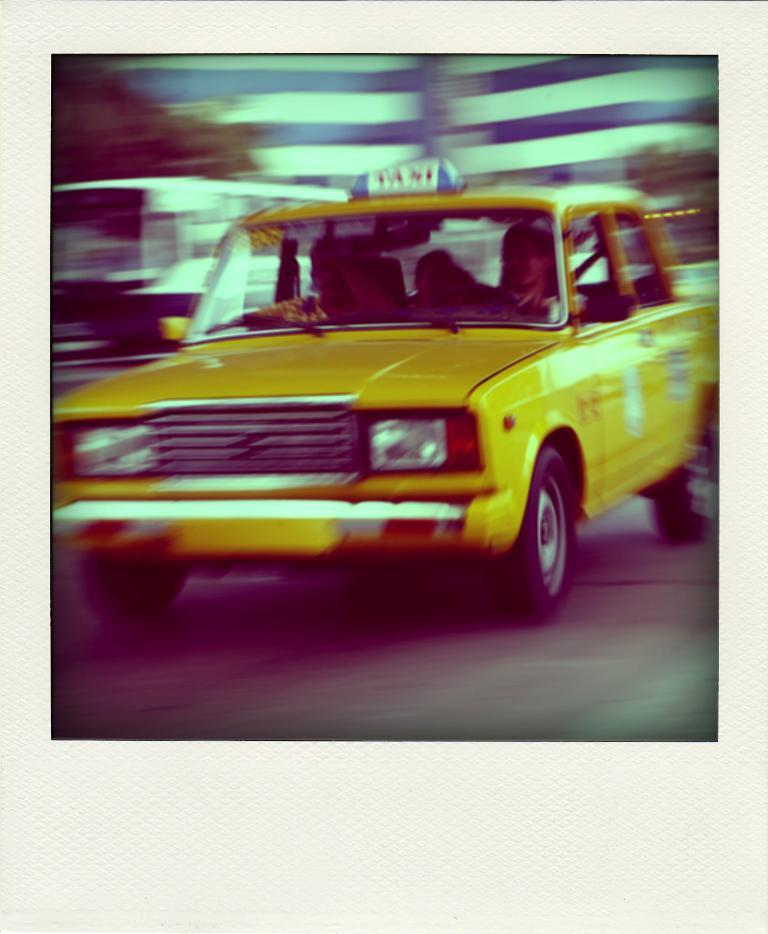<image>
Describe the image concisely. A yellow car has three people in it and a sign on top that says Taxi. 